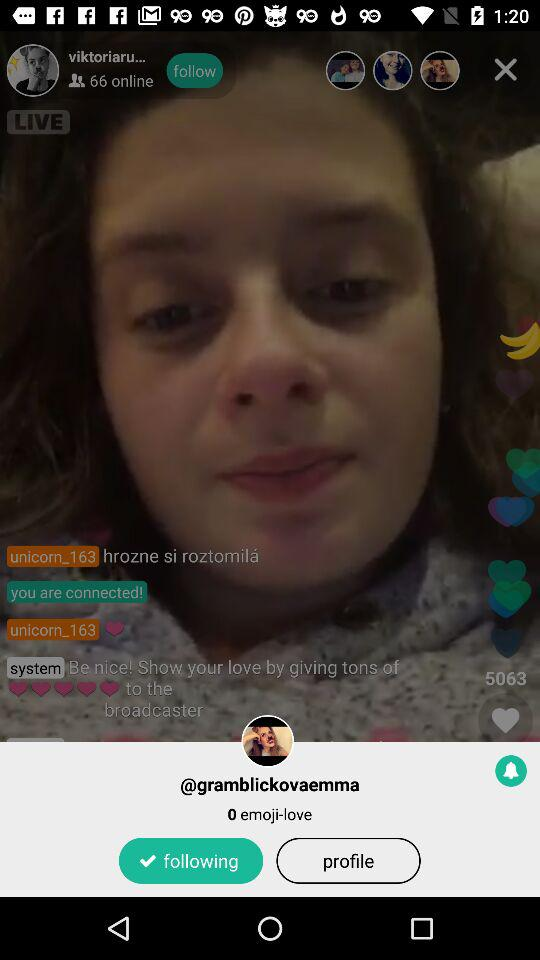How many online users are there? There are 66 online users. 